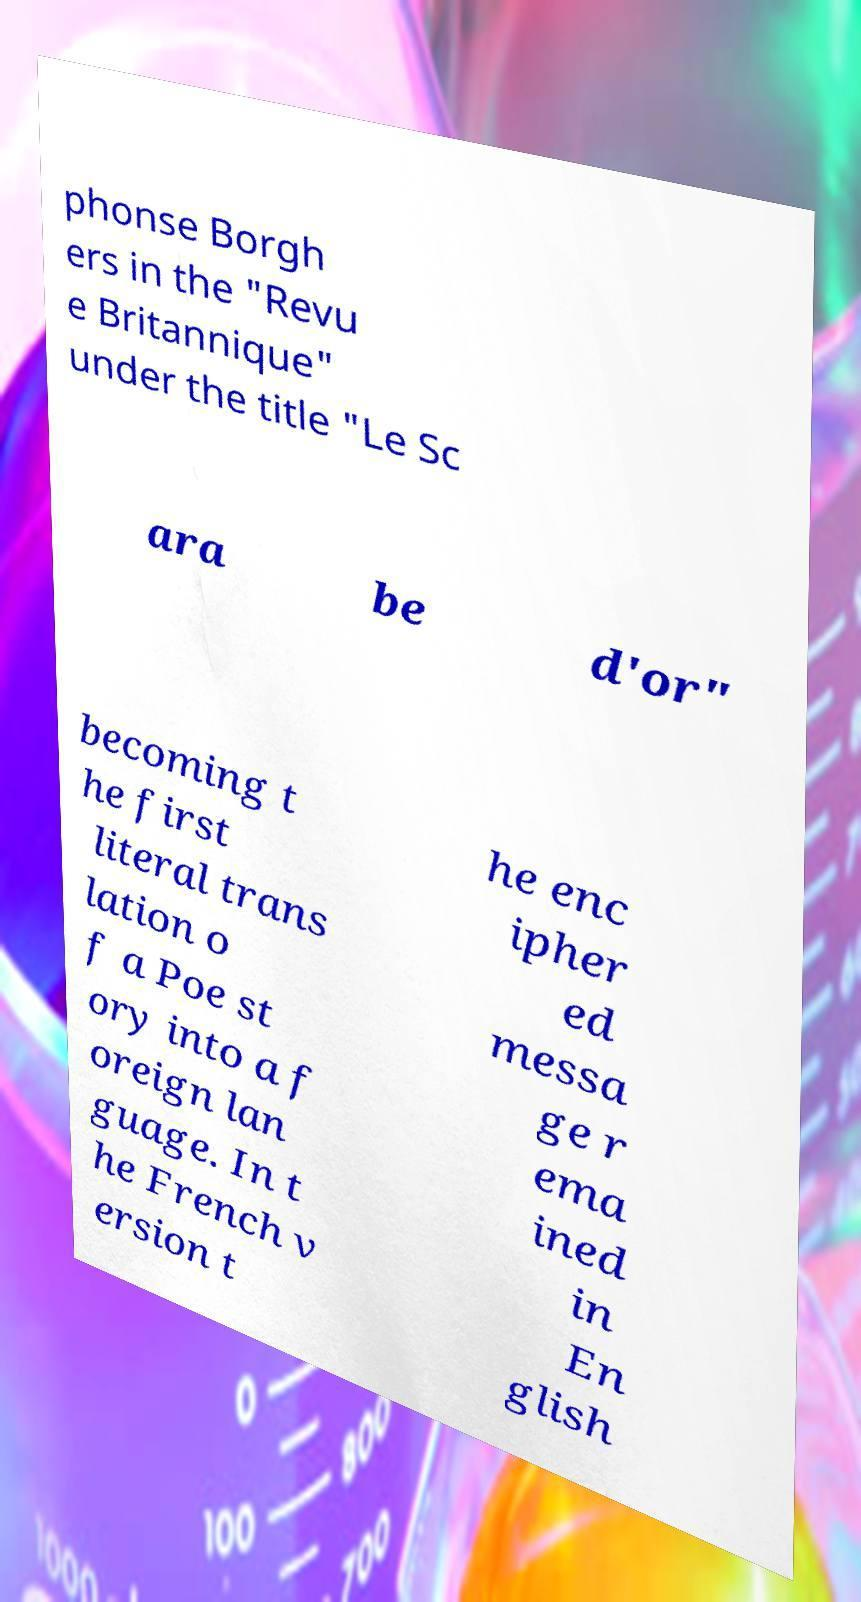Can you read and provide the text displayed in the image?This photo seems to have some interesting text. Can you extract and type it out for me? phonse Borgh ers in the "Revu e Britannique" under the title "Le Sc ara be d'or" becoming t he first literal trans lation o f a Poe st ory into a f oreign lan guage. In t he French v ersion t he enc ipher ed messa ge r ema ined in En glish 